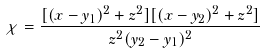Convert formula to latex. <formula><loc_0><loc_0><loc_500><loc_500>\chi = \frac { [ ( x - y _ { 1 } ) ^ { 2 } + z ^ { 2 } ] [ ( x - y _ { 2 } ) ^ { 2 } + z ^ { 2 } ] } { z ^ { 2 } ( y _ { 2 } - y _ { 1 } ) ^ { 2 } }</formula> 